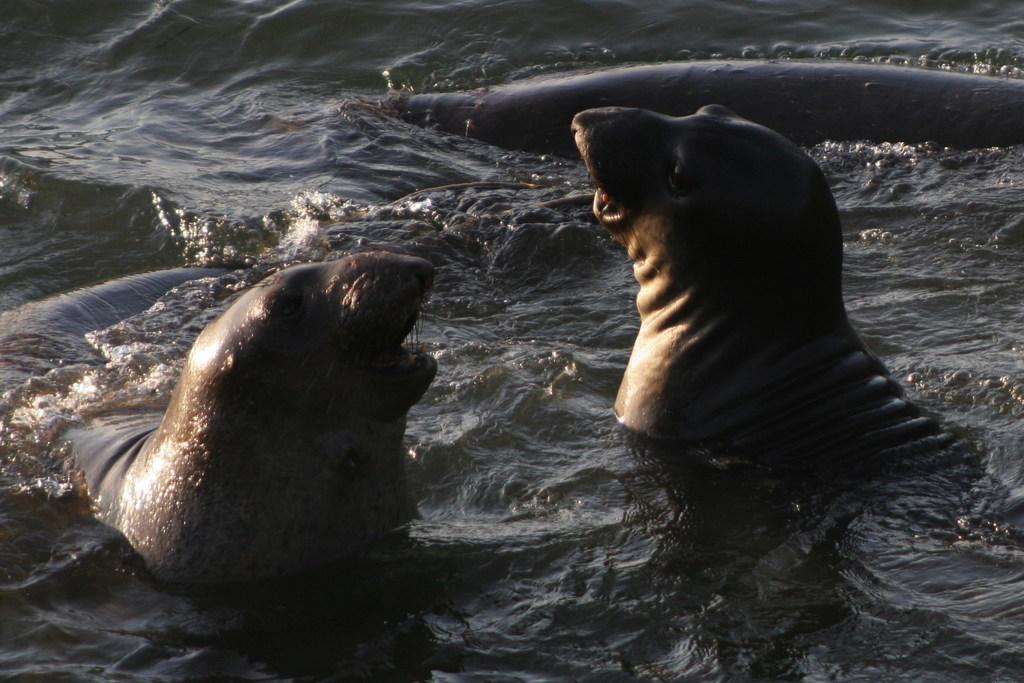What type of animals are present in the image? There are seals in the image. What is the primary element in which the seals are situated? There is water visible in the image, and the seals are in the water. What type of pan can be seen in the image? There is no pan present in the image; it features seals in water. 